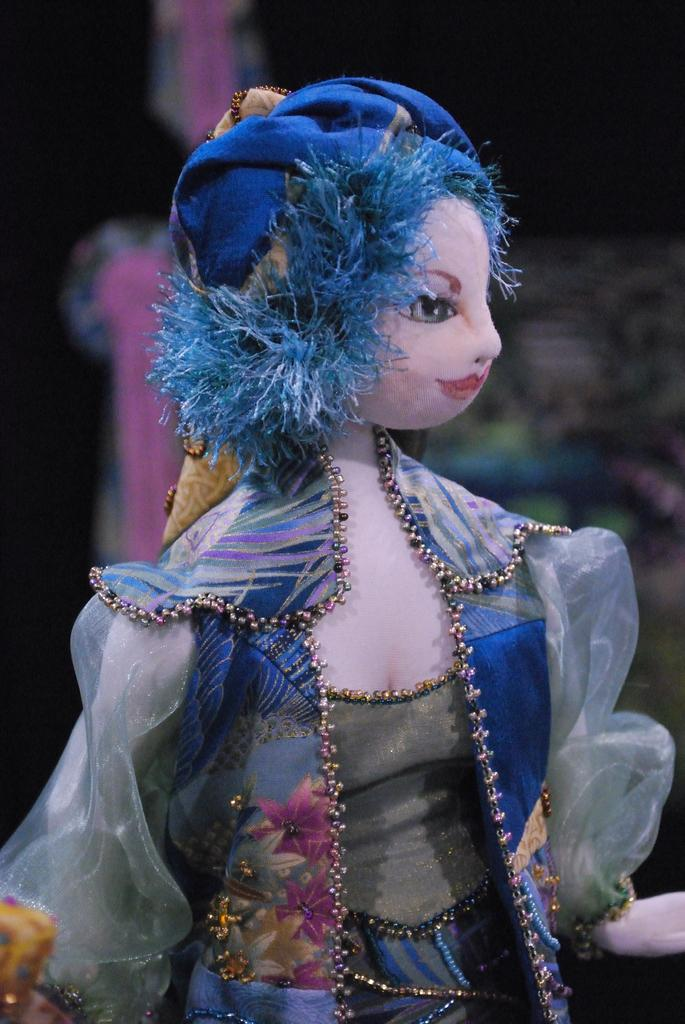What is the main subject in the foreground of the image? There is a doll in the foreground of the image. Can you describe the background of the image? The background of the image is blurred. What type of club does the daughter use to play with the doll in the image? There is no daughter or club present in the image; it only features a doll in the foreground. Can you describe the waves in the background of the image? There are no waves present in the image; the background is blurred, but no specific details about waves can be determined. 